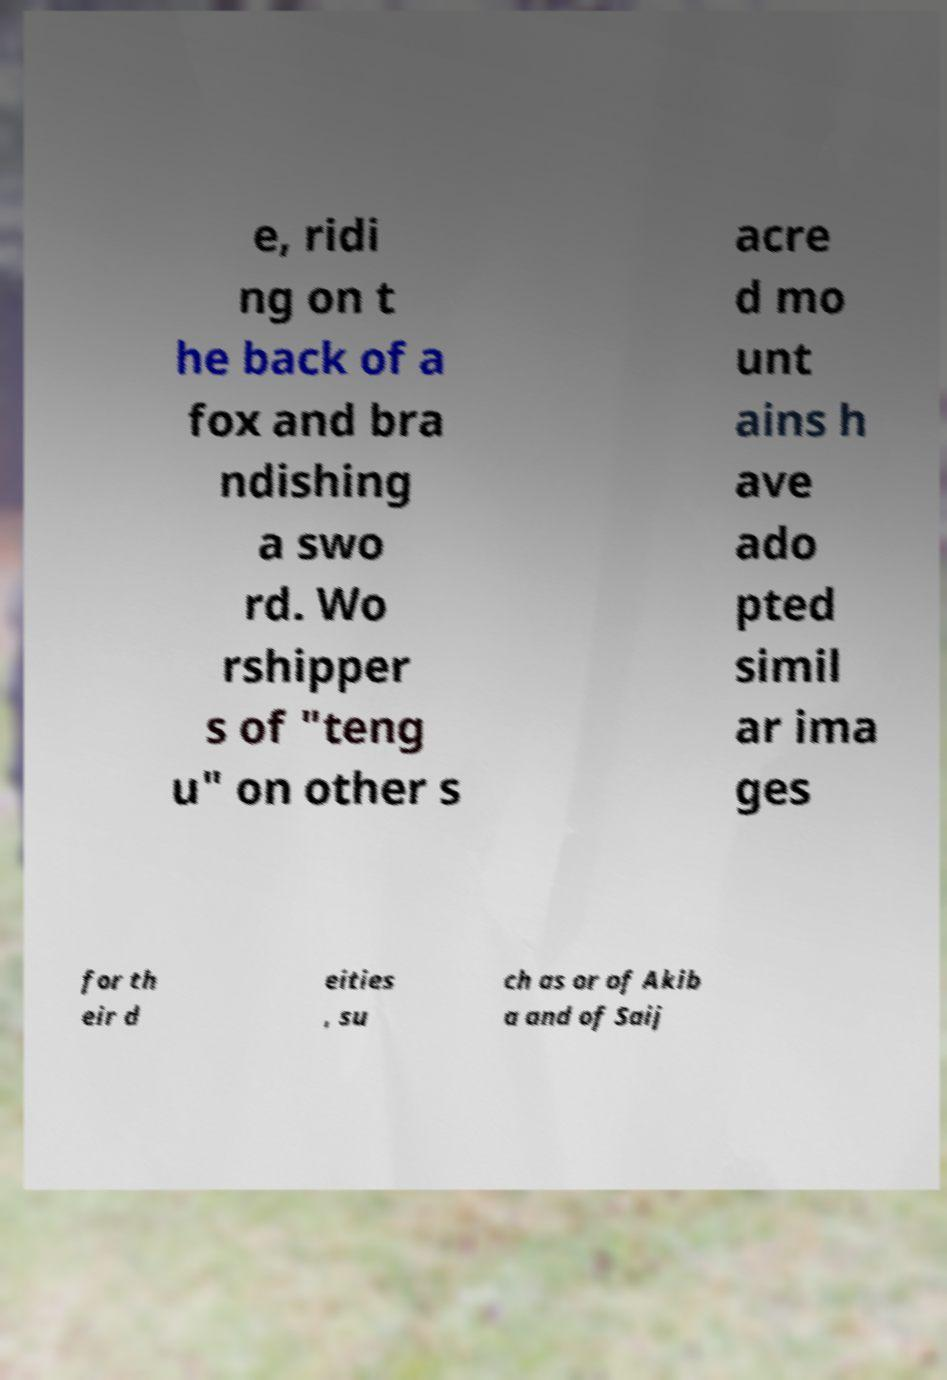There's text embedded in this image that I need extracted. Can you transcribe it verbatim? e, ridi ng on t he back of a fox and bra ndishing a swo rd. Wo rshipper s of "teng u" on other s acre d mo unt ains h ave ado pted simil ar ima ges for th eir d eities , su ch as or of Akib a and of Saij 